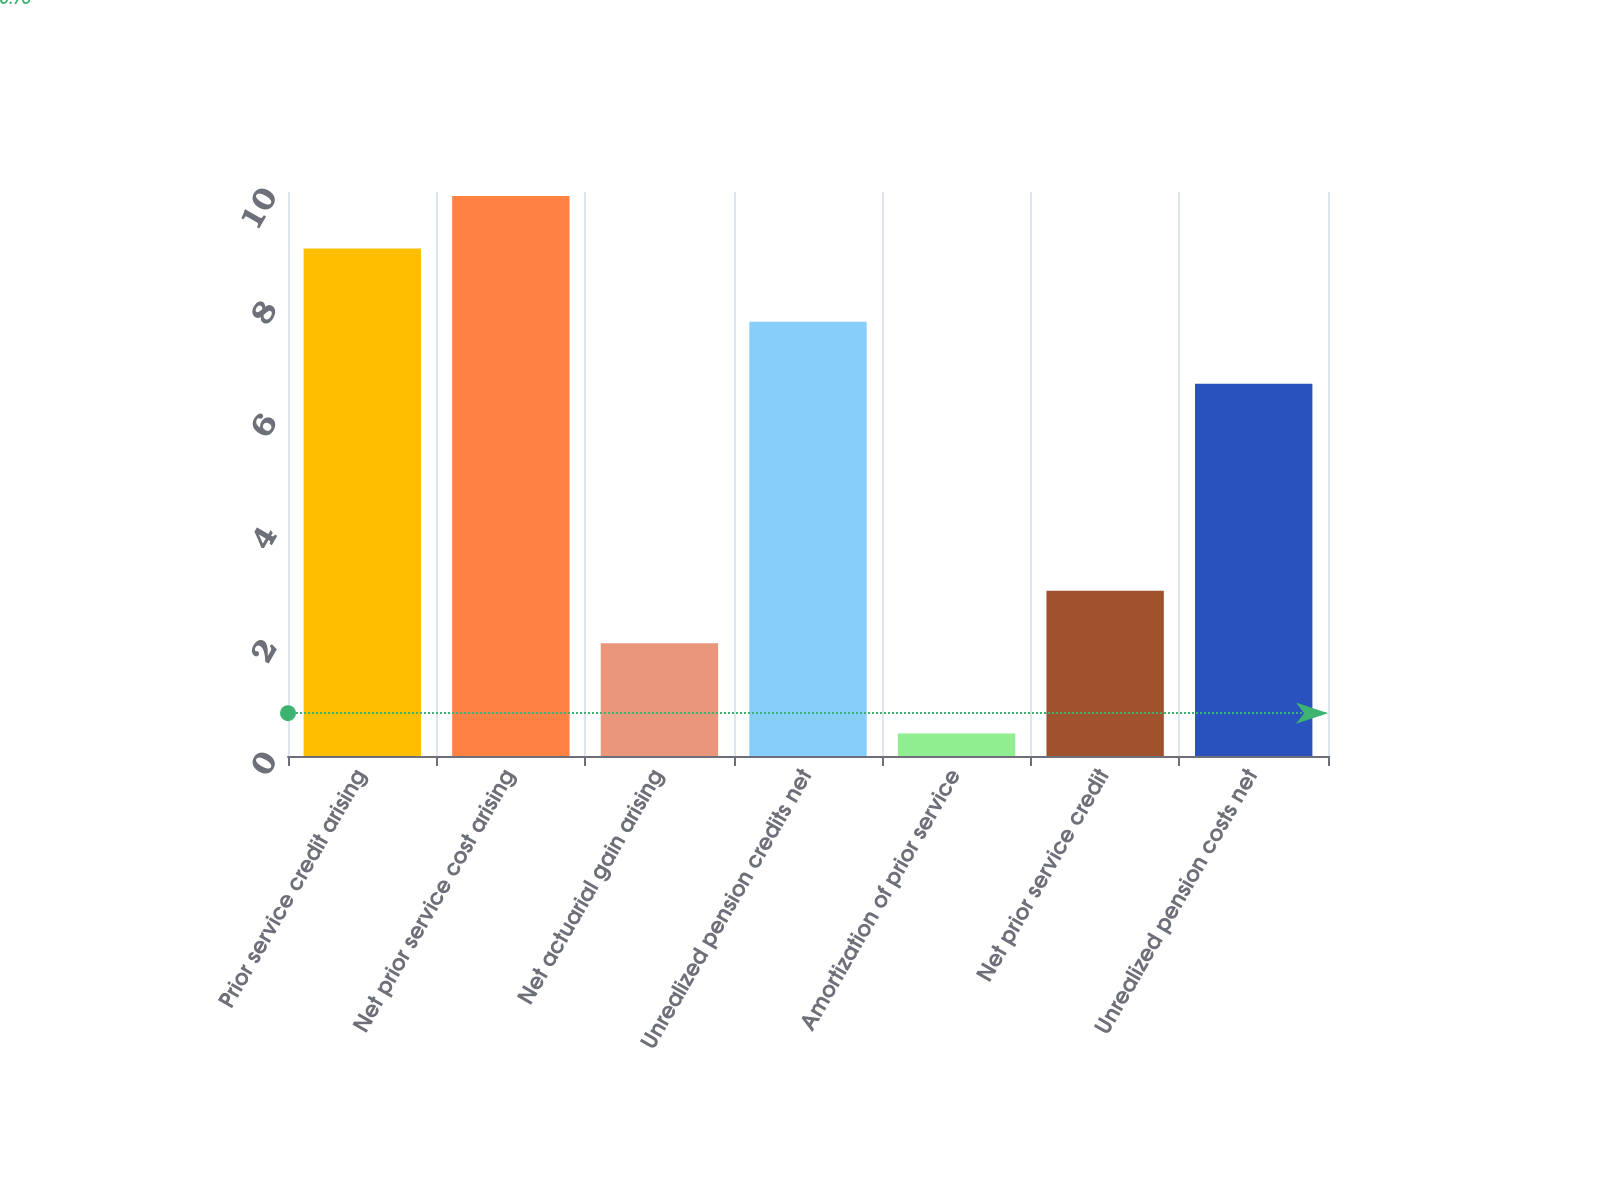Convert chart to OTSL. <chart><loc_0><loc_0><loc_500><loc_500><bar_chart><fcel>Prior service credit arising<fcel>Net prior service cost arising<fcel>Net actuarial gain arising<fcel>Unrealized pension credits net<fcel>Amortization of prior service<fcel>Net prior service credit<fcel>Unrealized pension costs net<nl><fcel>9<fcel>9.93<fcel>2<fcel>7.7<fcel>0.4<fcel>2.93<fcel>6.6<nl></chart> 